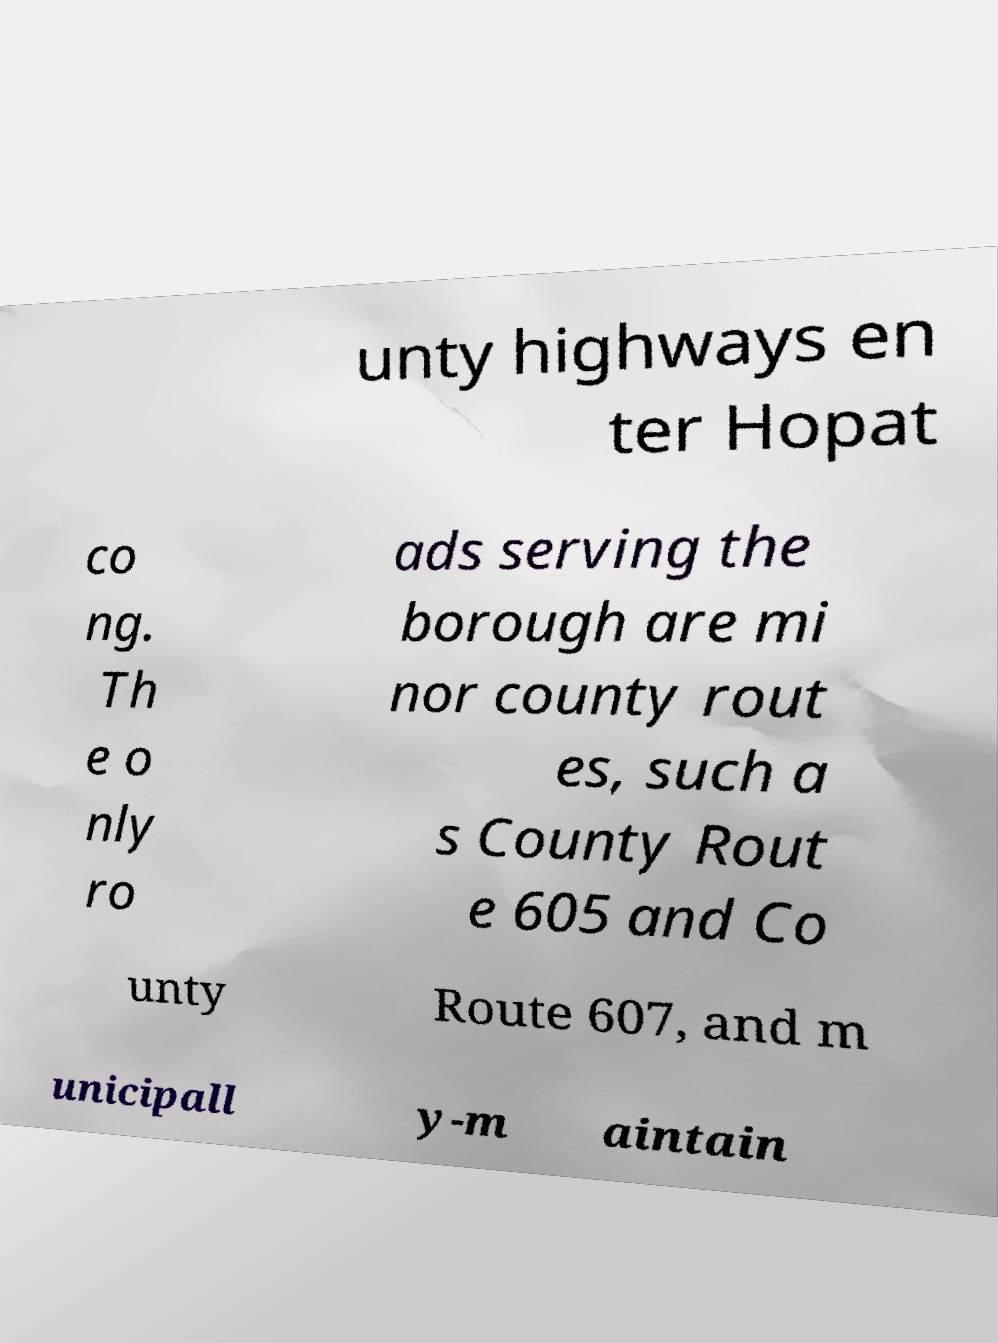There's text embedded in this image that I need extracted. Can you transcribe it verbatim? unty highways en ter Hopat co ng. Th e o nly ro ads serving the borough are mi nor county rout es, such a s County Rout e 605 and Co unty Route 607, and m unicipall y-m aintain 